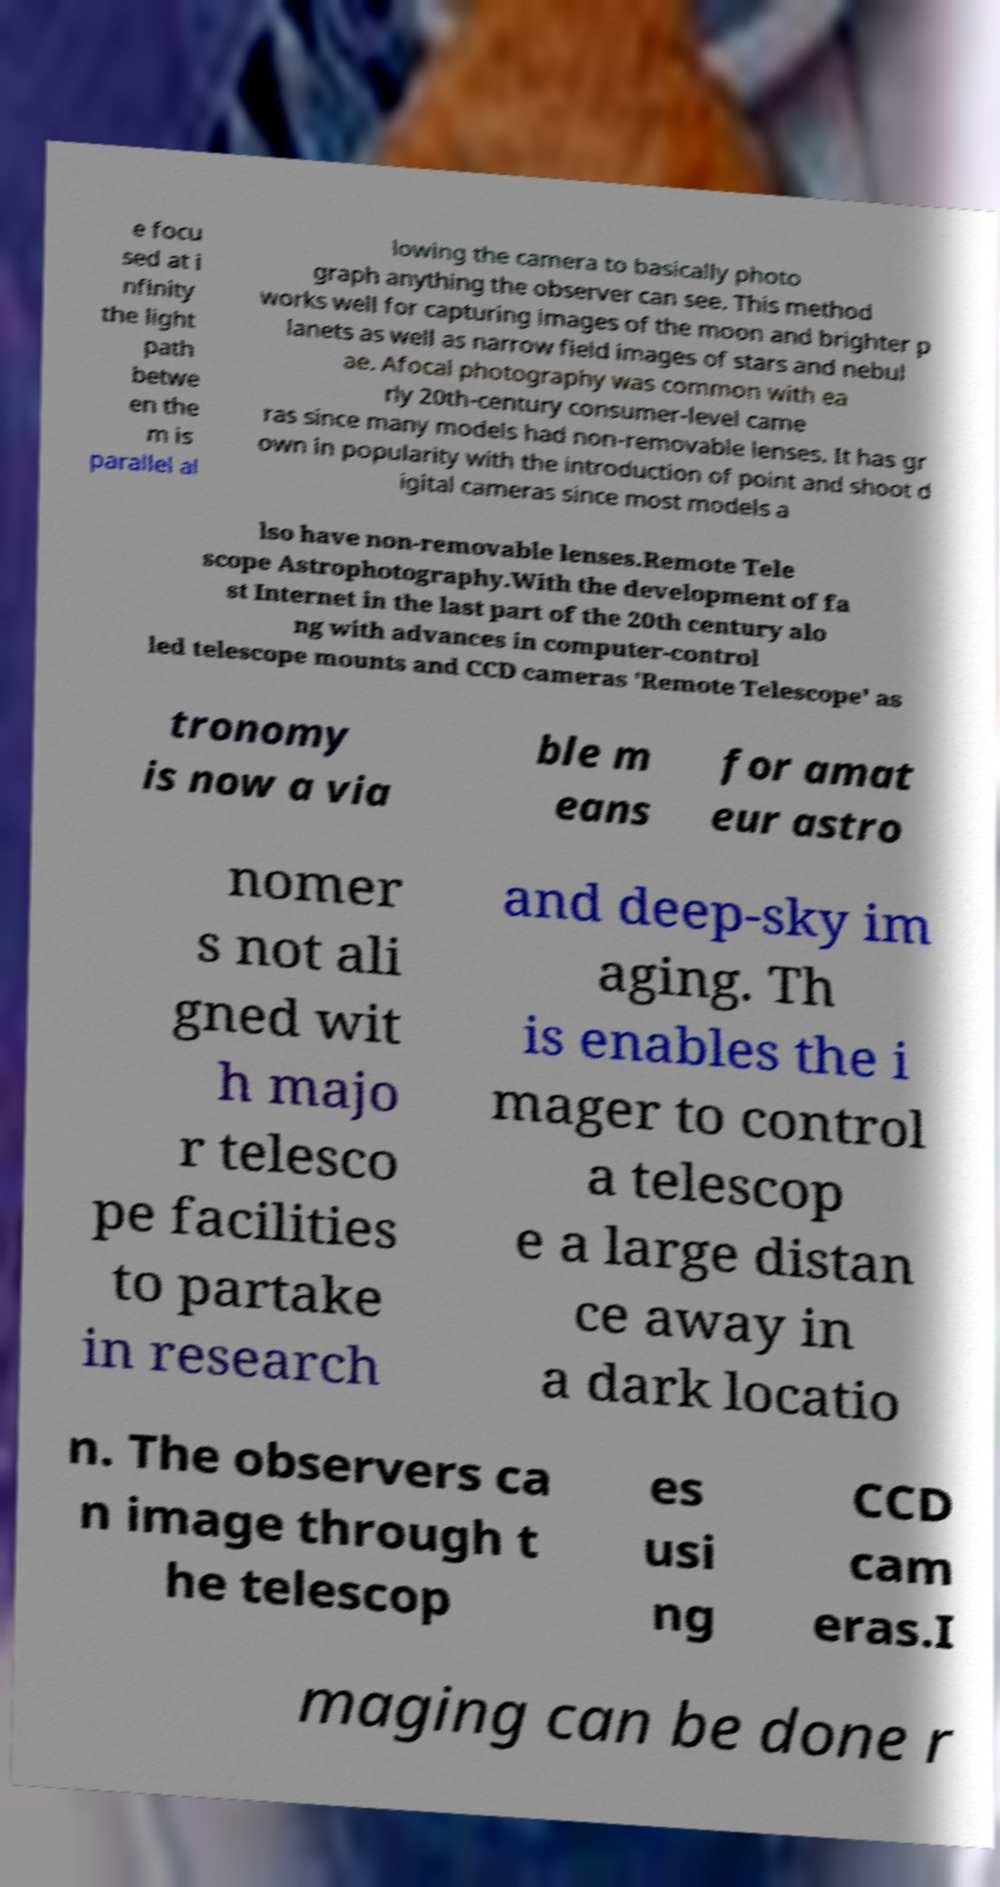Can you read and provide the text displayed in the image?This photo seems to have some interesting text. Can you extract and type it out for me? e focu sed at i nfinity the light path betwe en the m is parallel al lowing the camera to basically photo graph anything the observer can see. This method works well for capturing images of the moon and brighter p lanets as well as narrow field images of stars and nebul ae. Afocal photography was common with ea rly 20th-century consumer-level came ras since many models had non-removable lenses. It has gr own in popularity with the introduction of point and shoot d igital cameras since most models a lso have non-removable lenses.Remote Tele scope Astrophotography.With the development of fa st Internet in the last part of the 20th century alo ng with advances in computer-control led telescope mounts and CCD cameras 'Remote Telescope' as tronomy is now a via ble m eans for amat eur astro nomer s not ali gned wit h majo r telesco pe facilities to partake in research and deep-sky im aging. Th is enables the i mager to control a telescop e a large distan ce away in a dark locatio n. The observers ca n image through t he telescop es usi ng CCD cam eras.I maging can be done r 